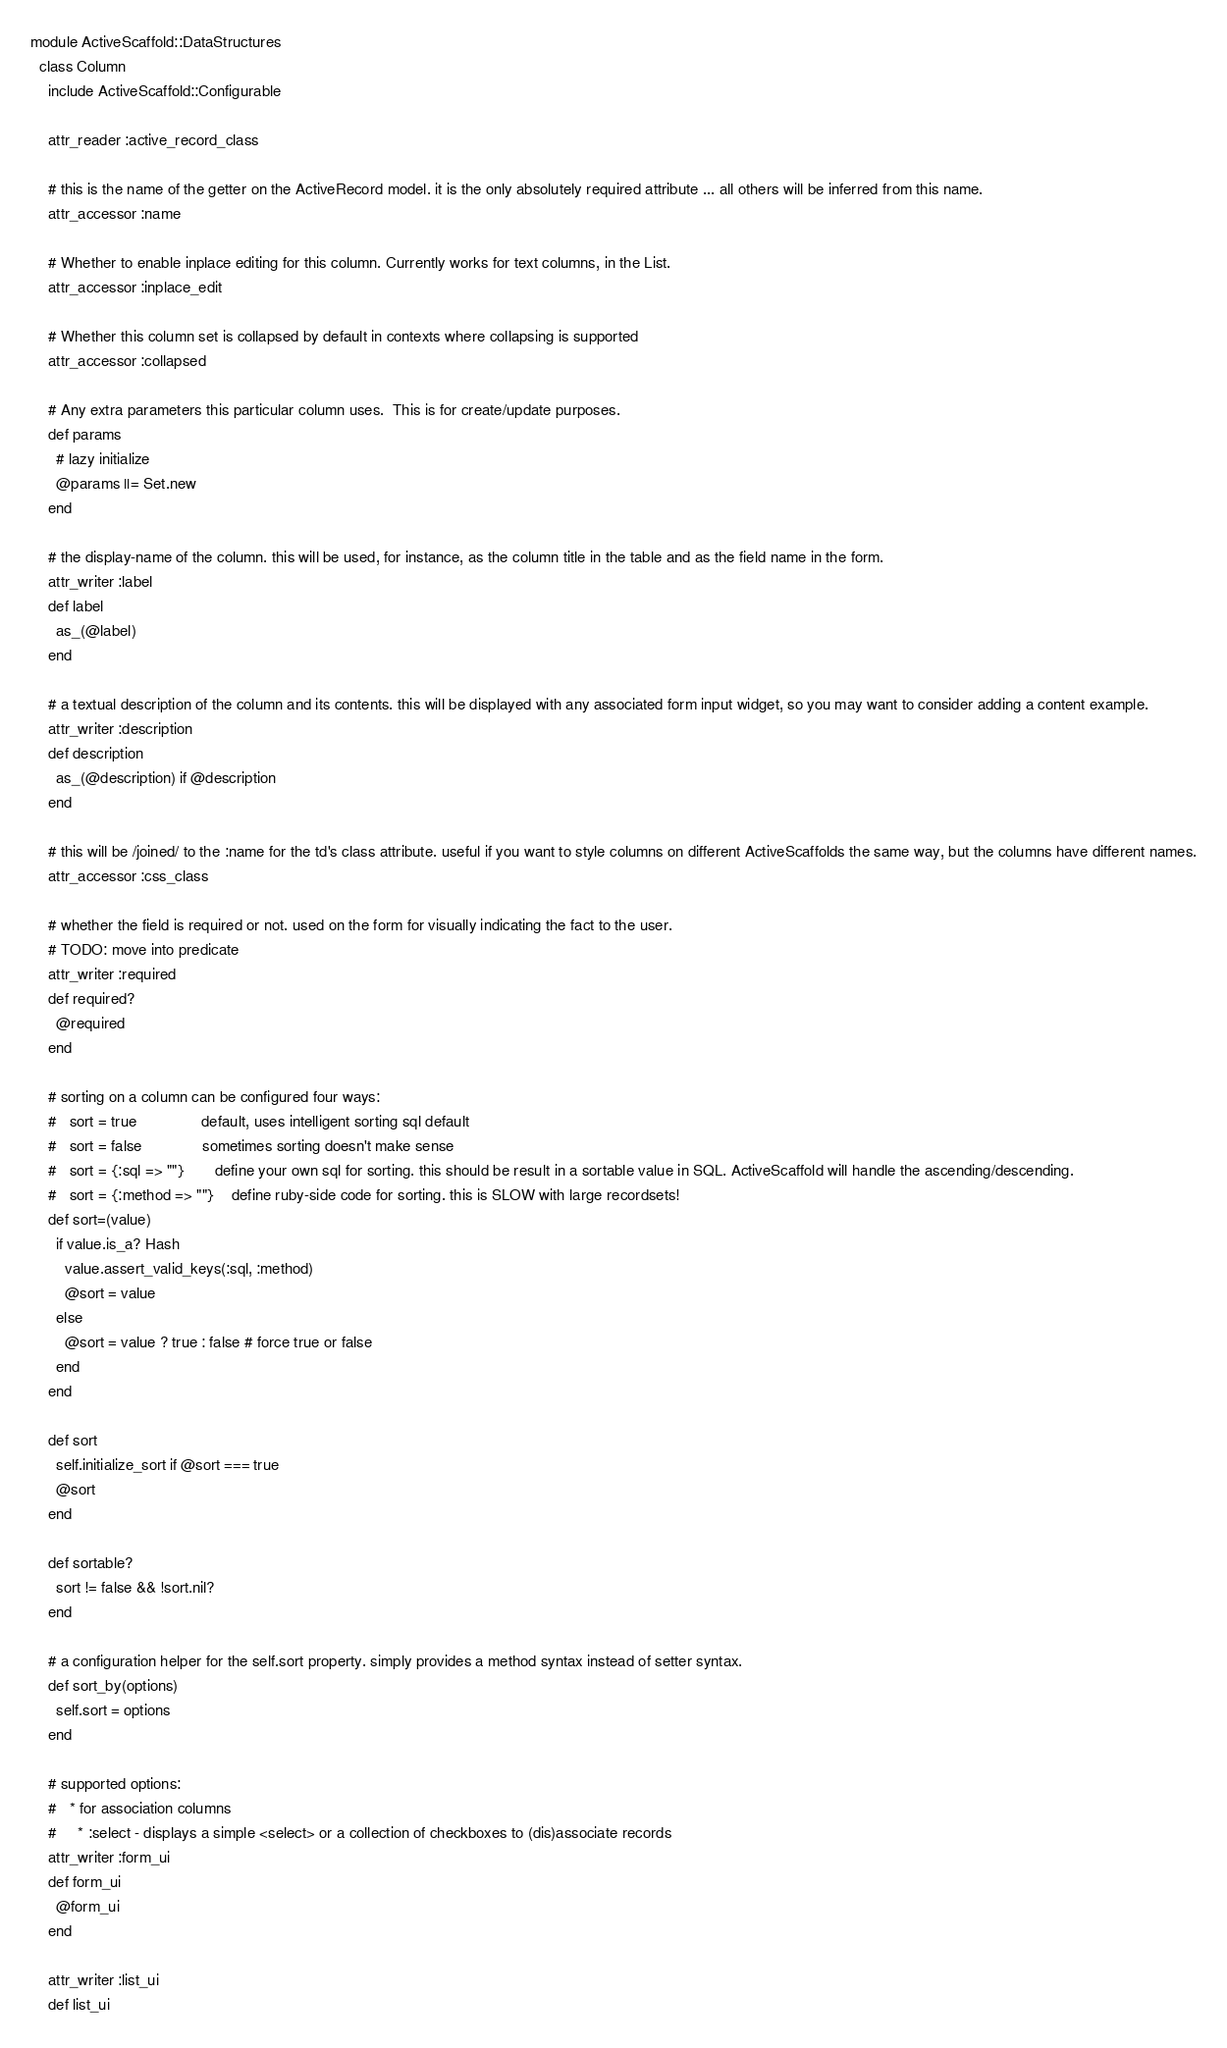Convert code to text. <code><loc_0><loc_0><loc_500><loc_500><_Ruby_>module ActiveScaffold::DataStructures
  class Column
    include ActiveScaffold::Configurable

    attr_reader :active_record_class

    # this is the name of the getter on the ActiveRecord model. it is the only absolutely required attribute ... all others will be inferred from this name.
    attr_accessor :name

    # Whether to enable inplace editing for this column. Currently works for text columns, in the List.
    attr_accessor :inplace_edit

    # Whether this column set is collapsed by default in contexts where collapsing is supported
    attr_accessor :collapsed
    
    # Any extra parameters this particular column uses.  This is for create/update purposes.
    def params
      # lazy initialize
      @params ||= Set.new
    end

    # the display-name of the column. this will be used, for instance, as the column title in the table and as the field name in the form.
    attr_writer :label
    def label
      as_(@label)
    end

    # a textual description of the column and its contents. this will be displayed with any associated form input widget, so you may want to consider adding a content example.
    attr_writer :description
    def description
      as_(@description) if @description
    end

    # this will be /joined/ to the :name for the td's class attribute. useful if you want to style columns on different ActiveScaffolds the same way, but the columns have different names.
    attr_accessor :css_class

    # whether the field is required or not. used on the form for visually indicating the fact to the user.
    # TODO: move into predicate
    attr_writer :required
    def required?
      @required
    end

    # sorting on a column can be configured four ways:
    #   sort = true               default, uses intelligent sorting sql default
    #   sort = false              sometimes sorting doesn't make sense
    #   sort = {:sql => ""}       define your own sql for sorting. this should be result in a sortable value in SQL. ActiveScaffold will handle the ascending/descending.
    #   sort = {:method => ""}    define ruby-side code for sorting. this is SLOW with large recordsets!
    def sort=(value)
      if value.is_a? Hash
        value.assert_valid_keys(:sql, :method)
        @sort = value
      else
        @sort = value ? true : false # force true or false
      end
    end

    def sort
      self.initialize_sort if @sort === true
      @sort
    end

    def sortable?
      sort != false && !sort.nil?
    end

    # a configuration helper for the self.sort property. simply provides a method syntax instead of setter syntax.
    def sort_by(options)
      self.sort = options
    end

    # supported options:
    #   * for association columns
    #     * :select - displays a simple <select> or a collection of checkboxes to (dis)associate records
    attr_writer :form_ui
    def form_ui
      @form_ui
    end

    attr_writer :list_ui
    def list_ui</code> 